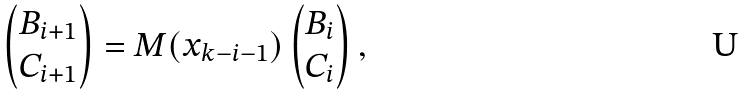<formula> <loc_0><loc_0><loc_500><loc_500>\begin{pmatrix} B _ { i + 1 } \\ C _ { i + 1 } \end{pmatrix} = M ( x _ { k - i - 1 } ) \begin{pmatrix} B _ { i } \\ C _ { i } \end{pmatrix} ,</formula> 